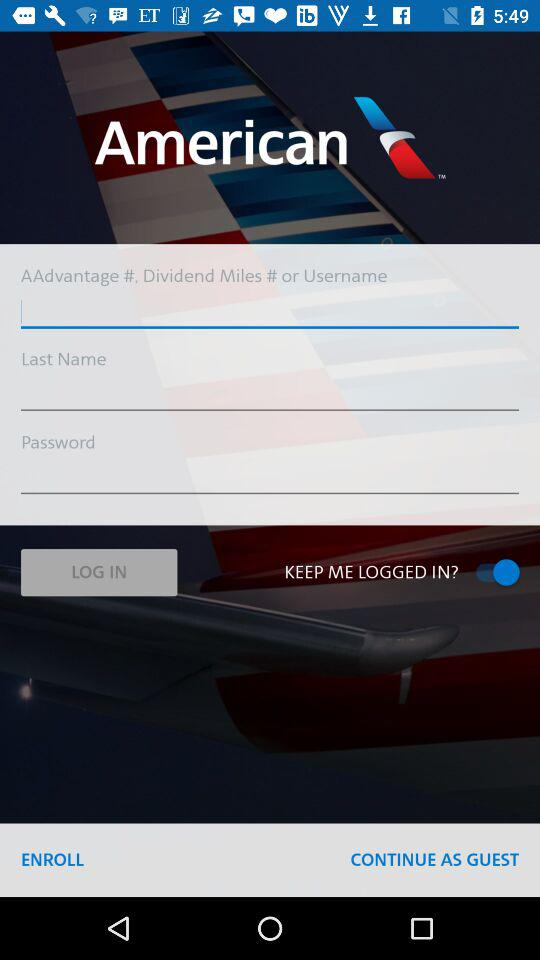What is the current status of "KEEP ME LOGGED IN?"? The current status is "on". 